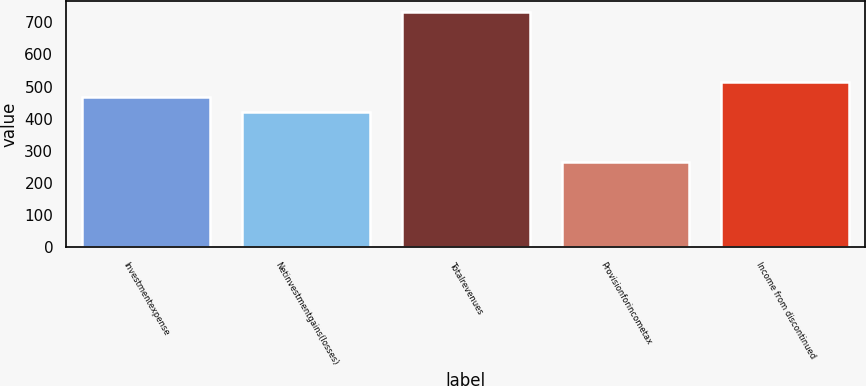<chart> <loc_0><loc_0><loc_500><loc_500><bar_chart><fcel>Investmentexpense<fcel>Netinvestmentgains(losses)<fcel>Totalrevenues<fcel>Provisionforincometax<fcel>Income from discontinued<nl><fcel>466.5<fcel>420<fcel>731<fcel>266<fcel>513<nl></chart> 